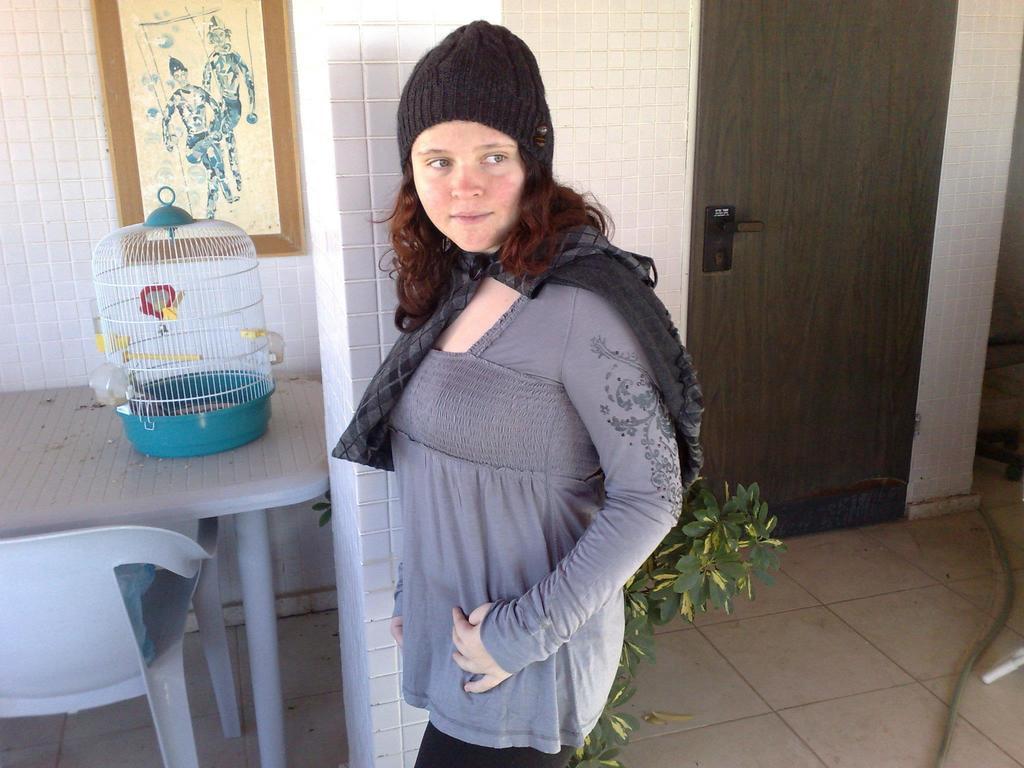Can you describe this image briefly? In this picture I can see there is a woman standing here and there is a cage here on the table and there is a door, wall in the backdrop. 